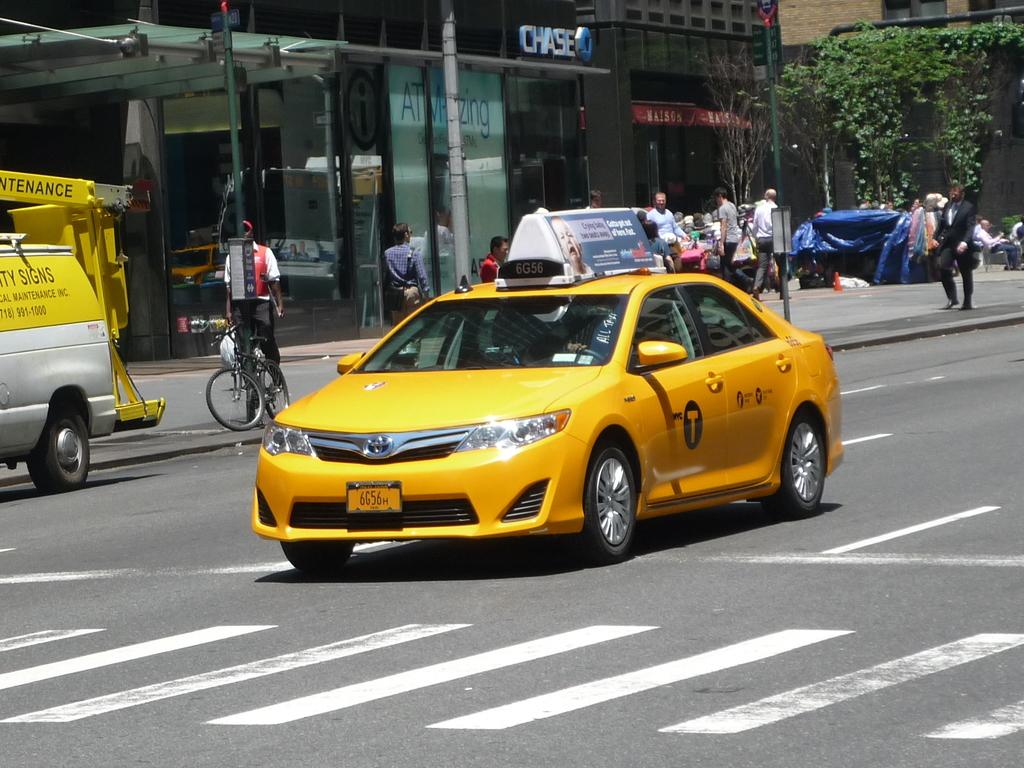What bank is seen in the background?
Give a very brief answer. Chase. What colour is the taxi?
Provide a succinct answer. Answering does not require reading text in the image. 